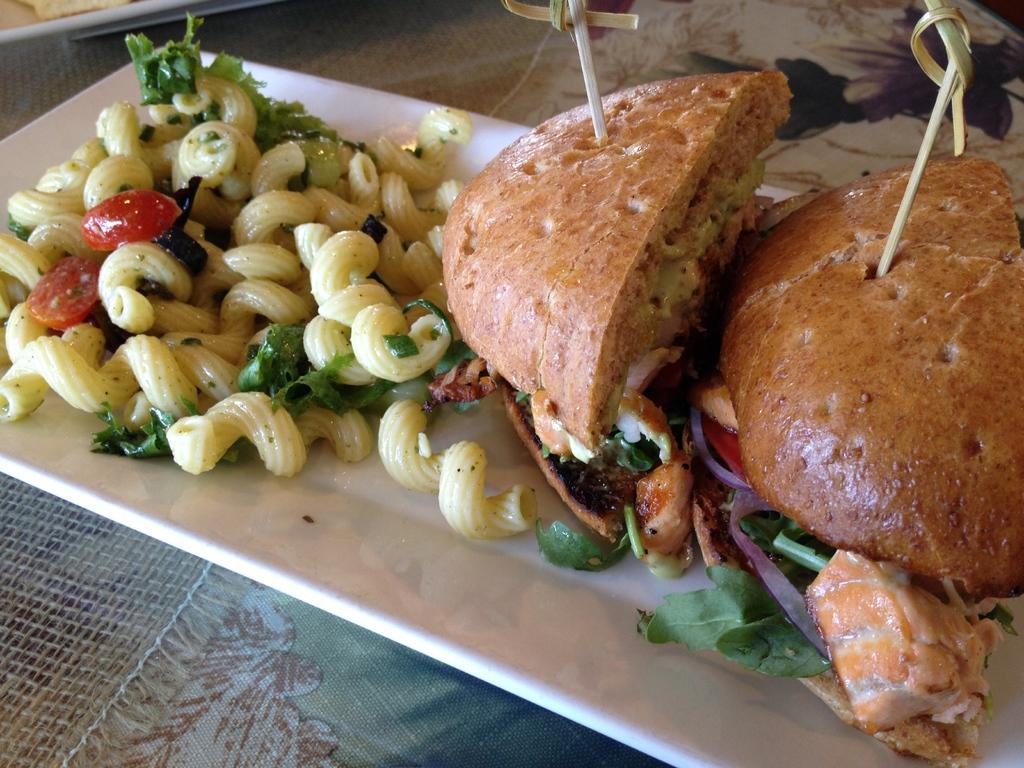What is on the plate in the image? There are food items on a plate. What is the plate resting on? The plate is on an object. Can you see any goldfish swimming in the channel in the image? There is no mention of a channel or goldfish in the provided facts, so we cannot answer this question based on the image. 